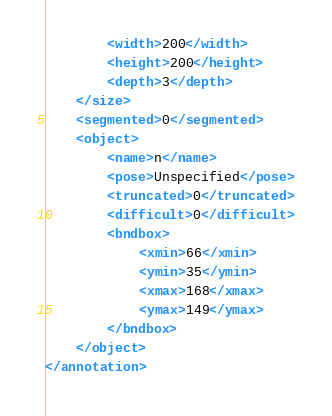Convert code to text. <code><loc_0><loc_0><loc_500><loc_500><_XML_>		<width>200</width>
		<height>200</height>
		<depth>3</depth>
	</size>
	<segmented>0</segmented>
	<object>
		<name>n</name>
		<pose>Unspecified</pose>
		<truncated>0</truncated>
		<difficult>0</difficult>
		<bndbox>
			<xmin>66</xmin>
			<ymin>35</ymin>
			<xmax>168</xmax>
			<ymax>149</ymax>
		</bndbox>
	</object>
</annotation>
</code> 